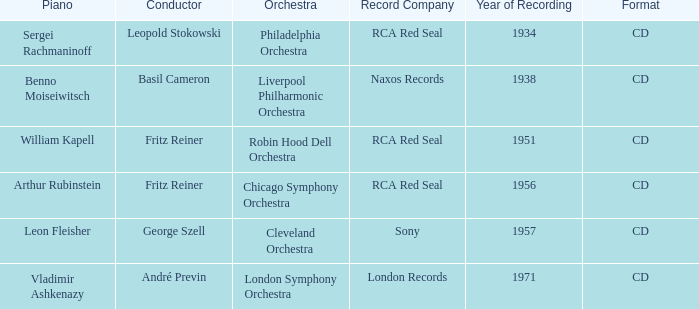Which musical ensemble has a 1951 recording year? Robin Hood Dell Orchestra. 